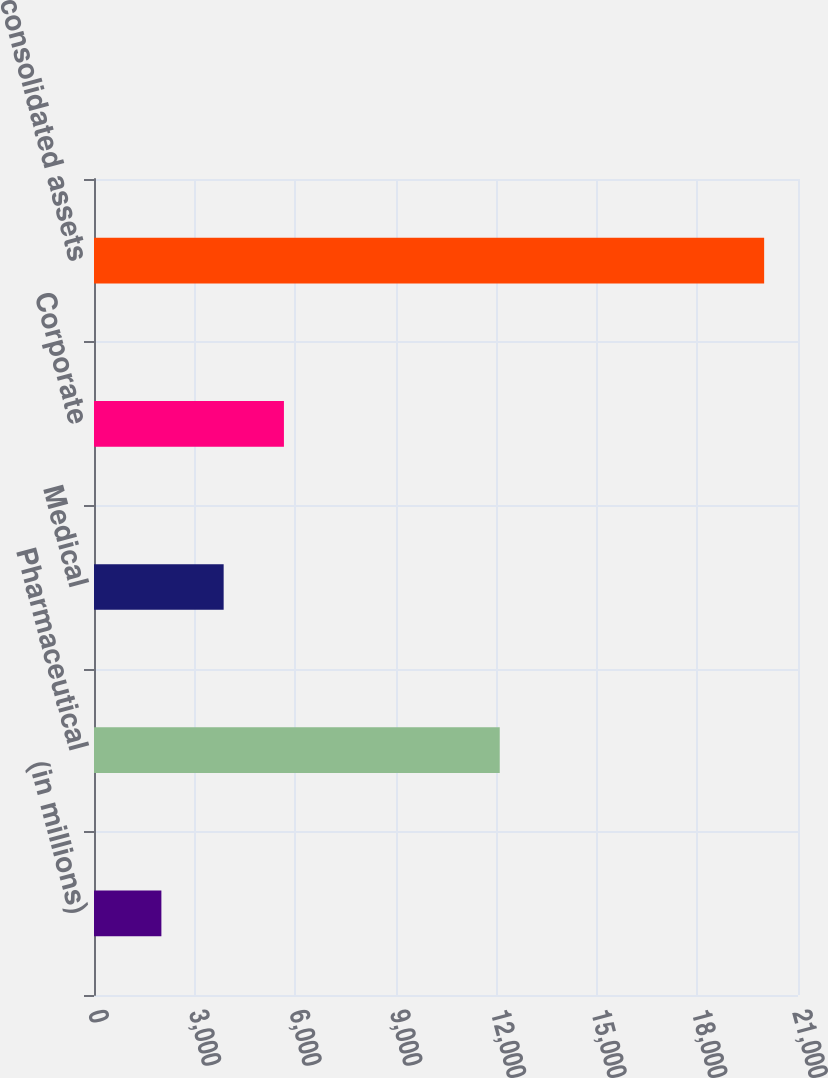Convert chart. <chart><loc_0><loc_0><loc_500><loc_500><bar_chart><fcel>(in millions)<fcel>Pharmaceutical<fcel>Medical<fcel>Corporate<fcel>Total consolidated assets<nl><fcel>2010<fcel>12102.9<fcel>3867.5<fcel>5665.52<fcel>19990.2<nl></chart> 